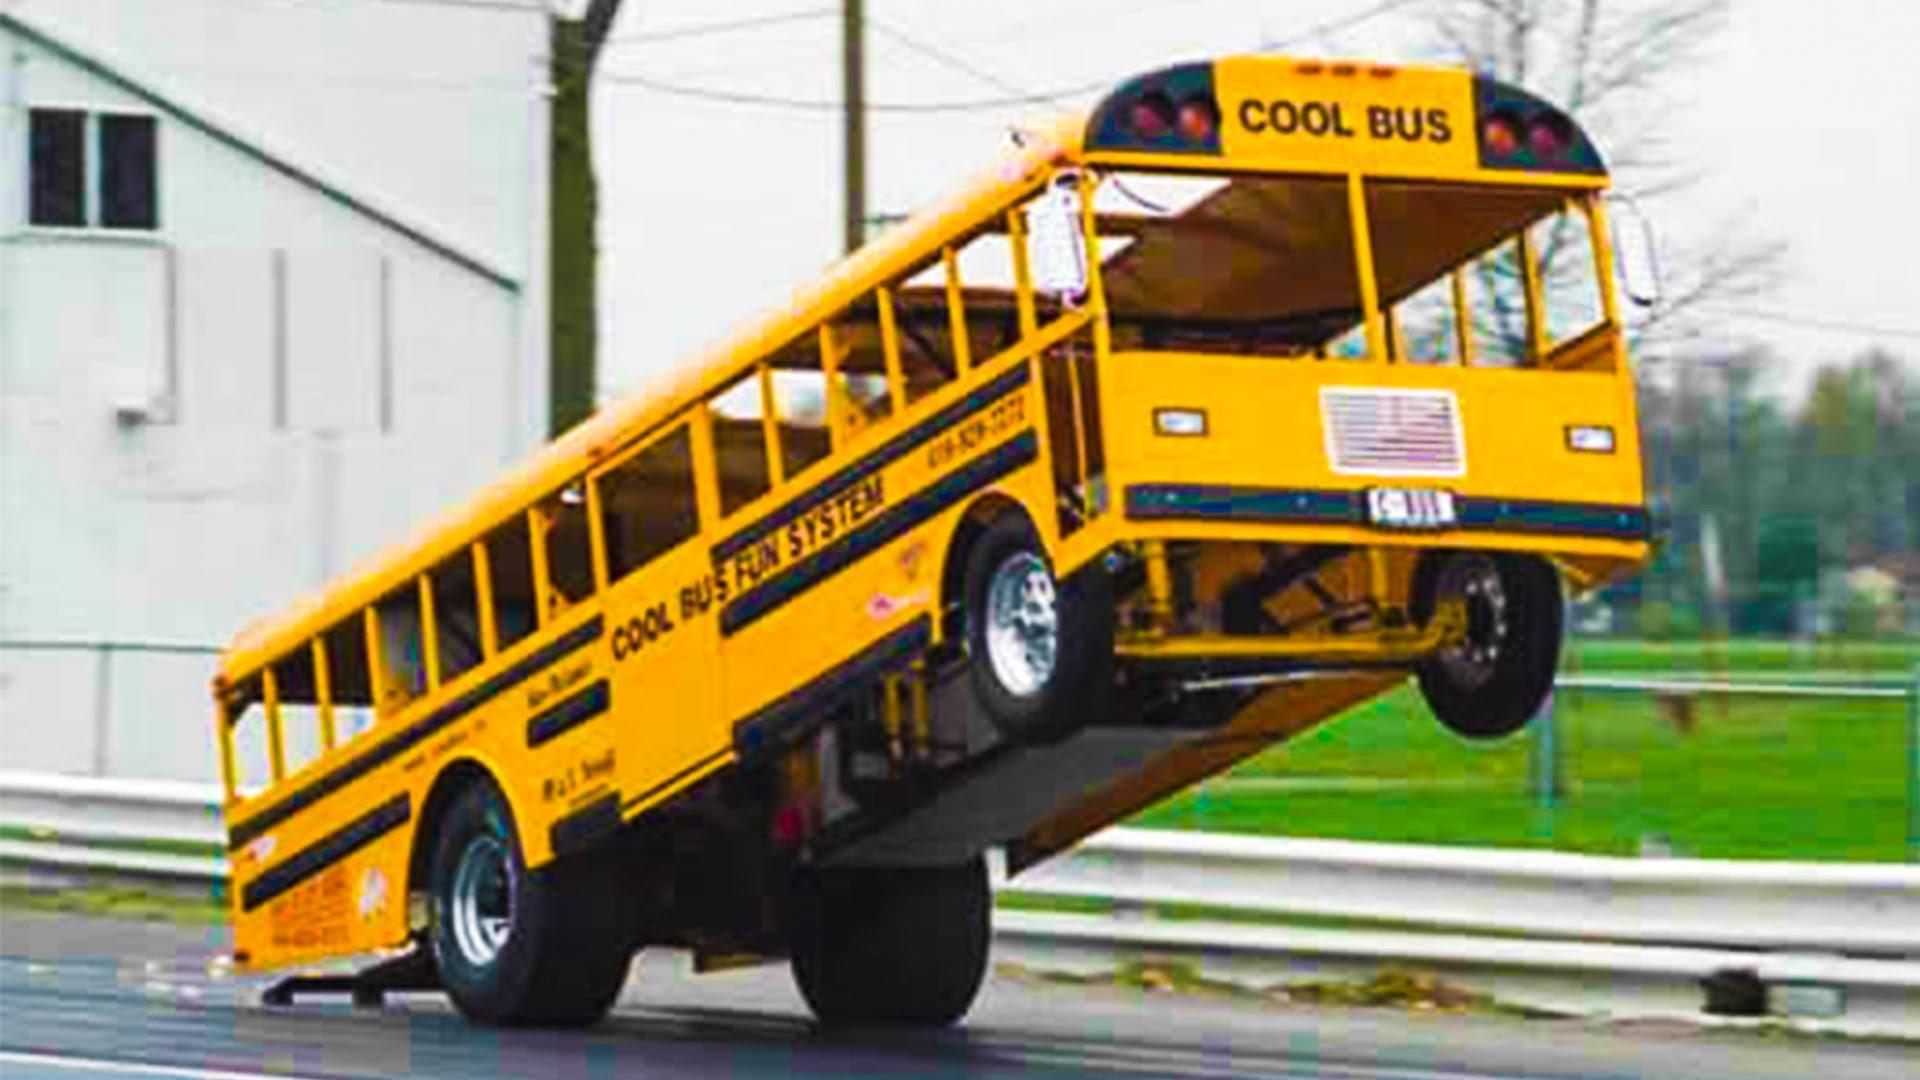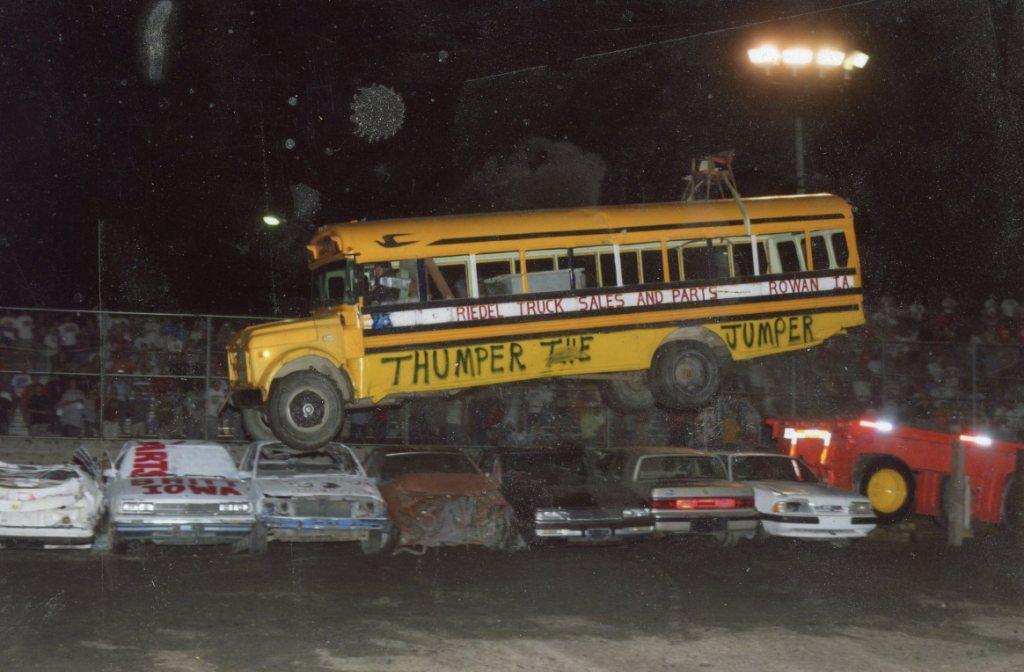The first image is the image on the left, the second image is the image on the right. Assess this claim about the two images: "The right image contains a school bus that is airborne being launched over objects.". Correct or not? Answer yes or no. Yes. The first image is the image on the left, the second image is the image on the right. For the images shown, is this caption "Both images feature buses performing stunts, and at least one image shows a yellow bus performing a wheelie with front wheels off the ground." true? Answer yes or no. Yes. 